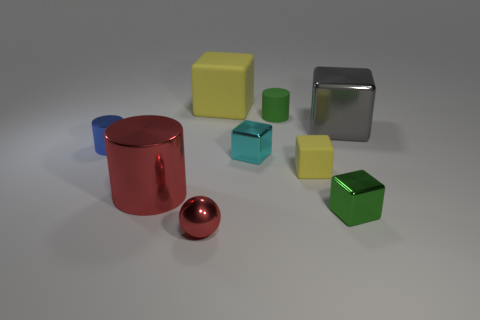There is a cylinder that is left of the large metallic cylinder; is it the same color as the large object in front of the big gray metal cube?
Make the answer very short. No. What number of other things are made of the same material as the large cylinder?
Make the answer very short. 5. Are any large yellow rubber objects visible?
Your answer should be compact. Yes. Are the green object in front of the gray object and the tiny blue thing made of the same material?
Provide a succinct answer. Yes. There is another small object that is the same shape as the tiny green matte thing; what is its material?
Provide a succinct answer. Metal. There is a cylinder that is the same color as the tiny ball; what material is it?
Provide a succinct answer. Metal. Is the number of purple metal balls less than the number of cyan cubes?
Your answer should be very brief. Yes. Is the color of the tiny shiny object that is in front of the tiny green block the same as the large rubber object?
Give a very brief answer. No. What is the color of the cylinder that is made of the same material as the big yellow cube?
Your answer should be very brief. Green. Do the green matte cylinder and the red metal ball have the same size?
Keep it short and to the point. Yes. 